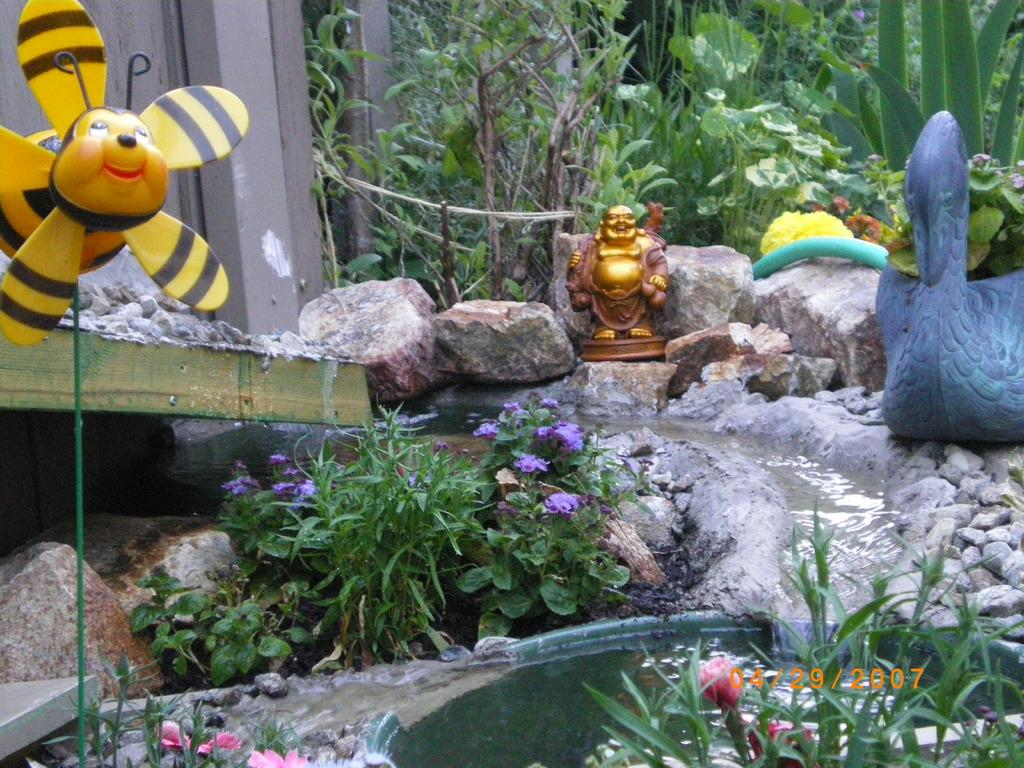What is visible in the image? Water, plants, rocks, and toys are visible in the image. Can you describe the natural elements in the image? There is water and plants visible in the image. What type of inanimate objects can be seen in the image? Rocks and toys are present in the image. What type of structure can be seen in the image? There is no structure present in the image; it features water, plants, rocks, and toys. What type of flag is visible in the image? There is no flag present in the image. 